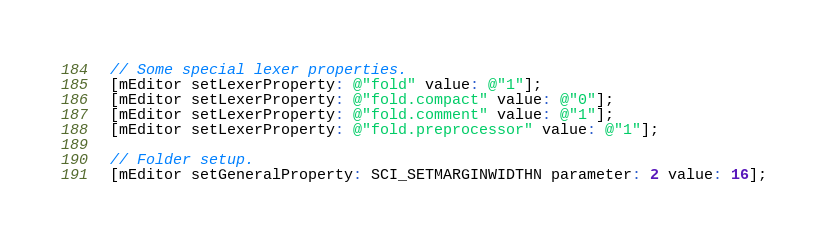<code> <loc_0><loc_0><loc_500><loc_500><_ObjectiveC_>  // Some special lexer properties.
  [mEditor setLexerProperty: @"fold" value: @"1"];
  [mEditor setLexerProperty: @"fold.compact" value: @"0"];
  [mEditor setLexerProperty: @"fold.comment" value: @"1"];
  [mEditor setLexerProperty: @"fold.preprocessor" value: @"1"];
  
  // Folder setup.
  [mEditor setGeneralProperty: SCI_SETMARGINWIDTHN parameter: 2 value: 16];</code> 